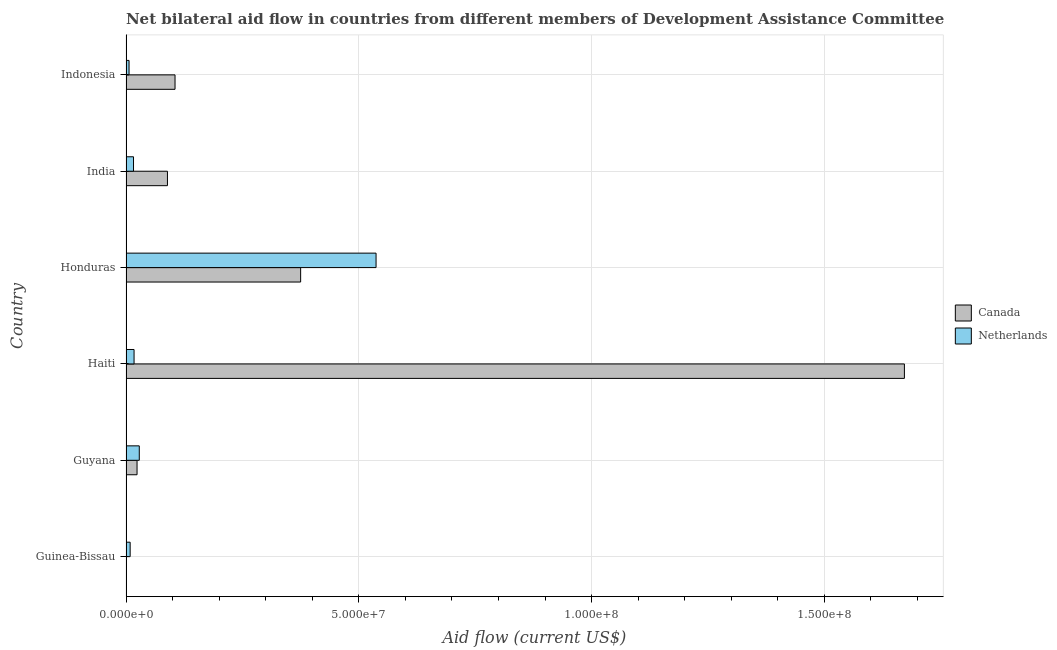How many different coloured bars are there?
Offer a terse response. 2. How many groups of bars are there?
Provide a succinct answer. 6. Are the number of bars on each tick of the Y-axis equal?
Give a very brief answer. Yes. How many bars are there on the 6th tick from the top?
Offer a very short reply. 2. What is the label of the 5th group of bars from the top?
Your answer should be compact. Guyana. In how many cases, is the number of bars for a given country not equal to the number of legend labels?
Your answer should be very brief. 0. What is the amount of aid given by canada in Guyana?
Keep it short and to the point. 2.37e+06. Across all countries, what is the maximum amount of aid given by canada?
Offer a very short reply. 1.67e+08. Across all countries, what is the minimum amount of aid given by netherlands?
Provide a short and direct response. 6.50e+05. In which country was the amount of aid given by canada maximum?
Provide a short and direct response. Haiti. What is the total amount of aid given by canada in the graph?
Your answer should be compact. 2.27e+08. What is the difference between the amount of aid given by canada in Guyana and that in Honduras?
Keep it short and to the point. -3.51e+07. What is the difference between the amount of aid given by canada in Indonesia and the amount of aid given by netherlands in India?
Give a very brief answer. 8.92e+06. What is the average amount of aid given by canada per country?
Your response must be concise. 3.78e+07. What is the difference between the amount of aid given by netherlands and amount of aid given by canada in Guyana?
Offer a very short reply. 4.80e+05. In how many countries, is the amount of aid given by canada greater than 110000000 US$?
Your answer should be compact. 1. What is the ratio of the amount of aid given by canada in Honduras to that in Indonesia?
Your response must be concise. 3.56. What is the difference between the highest and the second highest amount of aid given by canada?
Offer a very short reply. 1.30e+08. What is the difference between the highest and the lowest amount of aid given by canada?
Make the answer very short. 1.67e+08. What does the 2nd bar from the top in India represents?
Your answer should be compact. Canada. Are all the bars in the graph horizontal?
Your response must be concise. Yes. What is the difference between two consecutive major ticks on the X-axis?
Provide a succinct answer. 5.00e+07. Are the values on the major ticks of X-axis written in scientific E-notation?
Offer a terse response. Yes. Does the graph contain any zero values?
Your response must be concise. No. Where does the legend appear in the graph?
Ensure brevity in your answer.  Center right. How are the legend labels stacked?
Offer a terse response. Vertical. What is the title of the graph?
Ensure brevity in your answer.  Net bilateral aid flow in countries from different members of Development Assistance Committee. What is the label or title of the X-axis?
Give a very brief answer. Aid flow (current US$). What is the Aid flow (current US$) of Canada in Guinea-Bissau?
Your answer should be compact. 5.00e+04. What is the Aid flow (current US$) of Netherlands in Guinea-Bissau?
Offer a very short reply. 8.90e+05. What is the Aid flow (current US$) in Canada in Guyana?
Your answer should be very brief. 2.37e+06. What is the Aid flow (current US$) of Netherlands in Guyana?
Give a very brief answer. 2.85e+06. What is the Aid flow (current US$) of Canada in Haiti?
Provide a short and direct response. 1.67e+08. What is the Aid flow (current US$) in Netherlands in Haiti?
Give a very brief answer. 1.73e+06. What is the Aid flow (current US$) of Canada in Honduras?
Your answer should be very brief. 3.75e+07. What is the Aid flow (current US$) in Netherlands in Honduras?
Your answer should be compact. 5.37e+07. What is the Aid flow (current US$) of Canada in India?
Your answer should be compact. 8.90e+06. What is the Aid flow (current US$) in Netherlands in India?
Give a very brief answer. 1.61e+06. What is the Aid flow (current US$) of Canada in Indonesia?
Give a very brief answer. 1.05e+07. What is the Aid flow (current US$) in Netherlands in Indonesia?
Give a very brief answer. 6.50e+05. Across all countries, what is the maximum Aid flow (current US$) in Canada?
Provide a short and direct response. 1.67e+08. Across all countries, what is the maximum Aid flow (current US$) of Netherlands?
Offer a very short reply. 5.37e+07. Across all countries, what is the minimum Aid flow (current US$) of Canada?
Give a very brief answer. 5.00e+04. Across all countries, what is the minimum Aid flow (current US$) in Netherlands?
Provide a succinct answer. 6.50e+05. What is the total Aid flow (current US$) in Canada in the graph?
Your answer should be very brief. 2.27e+08. What is the total Aid flow (current US$) in Netherlands in the graph?
Keep it short and to the point. 6.14e+07. What is the difference between the Aid flow (current US$) of Canada in Guinea-Bissau and that in Guyana?
Your answer should be very brief. -2.32e+06. What is the difference between the Aid flow (current US$) of Netherlands in Guinea-Bissau and that in Guyana?
Provide a succinct answer. -1.96e+06. What is the difference between the Aid flow (current US$) of Canada in Guinea-Bissau and that in Haiti?
Keep it short and to the point. -1.67e+08. What is the difference between the Aid flow (current US$) in Netherlands in Guinea-Bissau and that in Haiti?
Provide a short and direct response. -8.40e+05. What is the difference between the Aid flow (current US$) in Canada in Guinea-Bissau and that in Honduras?
Your answer should be very brief. -3.75e+07. What is the difference between the Aid flow (current US$) in Netherlands in Guinea-Bissau and that in Honduras?
Keep it short and to the point. -5.28e+07. What is the difference between the Aid flow (current US$) of Canada in Guinea-Bissau and that in India?
Provide a succinct answer. -8.85e+06. What is the difference between the Aid flow (current US$) in Netherlands in Guinea-Bissau and that in India?
Ensure brevity in your answer.  -7.20e+05. What is the difference between the Aid flow (current US$) of Canada in Guinea-Bissau and that in Indonesia?
Ensure brevity in your answer.  -1.05e+07. What is the difference between the Aid flow (current US$) in Canada in Guyana and that in Haiti?
Ensure brevity in your answer.  -1.65e+08. What is the difference between the Aid flow (current US$) of Netherlands in Guyana and that in Haiti?
Your answer should be compact. 1.12e+06. What is the difference between the Aid flow (current US$) in Canada in Guyana and that in Honduras?
Provide a short and direct response. -3.51e+07. What is the difference between the Aid flow (current US$) of Netherlands in Guyana and that in Honduras?
Ensure brevity in your answer.  -5.09e+07. What is the difference between the Aid flow (current US$) in Canada in Guyana and that in India?
Your answer should be very brief. -6.53e+06. What is the difference between the Aid flow (current US$) in Netherlands in Guyana and that in India?
Make the answer very short. 1.24e+06. What is the difference between the Aid flow (current US$) of Canada in Guyana and that in Indonesia?
Give a very brief answer. -8.16e+06. What is the difference between the Aid flow (current US$) of Netherlands in Guyana and that in Indonesia?
Offer a terse response. 2.20e+06. What is the difference between the Aid flow (current US$) in Canada in Haiti and that in Honduras?
Ensure brevity in your answer.  1.30e+08. What is the difference between the Aid flow (current US$) in Netherlands in Haiti and that in Honduras?
Offer a terse response. -5.20e+07. What is the difference between the Aid flow (current US$) of Canada in Haiti and that in India?
Provide a succinct answer. 1.58e+08. What is the difference between the Aid flow (current US$) of Canada in Haiti and that in Indonesia?
Your response must be concise. 1.57e+08. What is the difference between the Aid flow (current US$) of Netherlands in Haiti and that in Indonesia?
Your response must be concise. 1.08e+06. What is the difference between the Aid flow (current US$) in Canada in Honduras and that in India?
Make the answer very short. 2.86e+07. What is the difference between the Aid flow (current US$) in Netherlands in Honduras and that in India?
Ensure brevity in your answer.  5.21e+07. What is the difference between the Aid flow (current US$) of Canada in Honduras and that in Indonesia?
Your response must be concise. 2.70e+07. What is the difference between the Aid flow (current US$) in Netherlands in Honduras and that in Indonesia?
Keep it short and to the point. 5.31e+07. What is the difference between the Aid flow (current US$) in Canada in India and that in Indonesia?
Your response must be concise. -1.63e+06. What is the difference between the Aid flow (current US$) of Netherlands in India and that in Indonesia?
Your answer should be very brief. 9.60e+05. What is the difference between the Aid flow (current US$) in Canada in Guinea-Bissau and the Aid flow (current US$) in Netherlands in Guyana?
Your answer should be very brief. -2.80e+06. What is the difference between the Aid flow (current US$) of Canada in Guinea-Bissau and the Aid flow (current US$) of Netherlands in Haiti?
Provide a succinct answer. -1.68e+06. What is the difference between the Aid flow (current US$) of Canada in Guinea-Bissau and the Aid flow (current US$) of Netherlands in Honduras?
Offer a terse response. -5.37e+07. What is the difference between the Aid flow (current US$) in Canada in Guinea-Bissau and the Aid flow (current US$) in Netherlands in India?
Your response must be concise. -1.56e+06. What is the difference between the Aid flow (current US$) of Canada in Guinea-Bissau and the Aid flow (current US$) of Netherlands in Indonesia?
Keep it short and to the point. -6.00e+05. What is the difference between the Aid flow (current US$) in Canada in Guyana and the Aid flow (current US$) in Netherlands in Haiti?
Provide a succinct answer. 6.40e+05. What is the difference between the Aid flow (current US$) in Canada in Guyana and the Aid flow (current US$) in Netherlands in Honduras?
Your answer should be very brief. -5.13e+07. What is the difference between the Aid flow (current US$) of Canada in Guyana and the Aid flow (current US$) of Netherlands in India?
Ensure brevity in your answer.  7.60e+05. What is the difference between the Aid flow (current US$) of Canada in Guyana and the Aid flow (current US$) of Netherlands in Indonesia?
Your answer should be compact. 1.72e+06. What is the difference between the Aid flow (current US$) in Canada in Haiti and the Aid flow (current US$) in Netherlands in Honduras?
Your answer should be compact. 1.13e+08. What is the difference between the Aid flow (current US$) in Canada in Haiti and the Aid flow (current US$) in Netherlands in India?
Your response must be concise. 1.66e+08. What is the difference between the Aid flow (current US$) in Canada in Haiti and the Aid flow (current US$) in Netherlands in Indonesia?
Provide a succinct answer. 1.67e+08. What is the difference between the Aid flow (current US$) in Canada in Honduras and the Aid flow (current US$) in Netherlands in India?
Provide a succinct answer. 3.59e+07. What is the difference between the Aid flow (current US$) in Canada in Honduras and the Aid flow (current US$) in Netherlands in Indonesia?
Your answer should be compact. 3.69e+07. What is the difference between the Aid flow (current US$) in Canada in India and the Aid flow (current US$) in Netherlands in Indonesia?
Your answer should be compact. 8.25e+06. What is the average Aid flow (current US$) of Canada per country?
Ensure brevity in your answer.  3.78e+07. What is the average Aid flow (current US$) in Netherlands per country?
Provide a short and direct response. 1.02e+07. What is the difference between the Aid flow (current US$) of Canada and Aid flow (current US$) of Netherlands in Guinea-Bissau?
Your response must be concise. -8.40e+05. What is the difference between the Aid flow (current US$) in Canada and Aid flow (current US$) in Netherlands in Guyana?
Provide a short and direct response. -4.80e+05. What is the difference between the Aid flow (current US$) of Canada and Aid flow (current US$) of Netherlands in Haiti?
Offer a terse response. 1.65e+08. What is the difference between the Aid flow (current US$) in Canada and Aid flow (current US$) in Netherlands in Honduras?
Ensure brevity in your answer.  -1.62e+07. What is the difference between the Aid flow (current US$) of Canada and Aid flow (current US$) of Netherlands in India?
Give a very brief answer. 7.29e+06. What is the difference between the Aid flow (current US$) in Canada and Aid flow (current US$) in Netherlands in Indonesia?
Ensure brevity in your answer.  9.88e+06. What is the ratio of the Aid flow (current US$) of Canada in Guinea-Bissau to that in Guyana?
Offer a terse response. 0.02. What is the ratio of the Aid flow (current US$) of Netherlands in Guinea-Bissau to that in Guyana?
Your response must be concise. 0.31. What is the ratio of the Aid flow (current US$) in Canada in Guinea-Bissau to that in Haiti?
Offer a terse response. 0. What is the ratio of the Aid flow (current US$) of Netherlands in Guinea-Bissau to that in Haiti?
Your answer should be compact. 0.51. What is the ratio of the Aid flow (current US$) of Canada in Guinea-Bissau to that in Honduras?
Your response must be concise. 0. What is the ratio of the Aid flow (current US$) of Netherlands in Guinea-Bissau to that in Honduras?
Give a very brief answer. 0.02. What is the ratio of the Aid flow (current US$) in Canada in Guinea-Bissau to that in India?
Offer a very short reply. 0.01. What is the ratio of the Aid flow (current US$) in Netherlands in Guinea-Bissau to that in India?
Ensure brevity in your answer.  0.55. What is the ratio of the Aid flow (current US$) of Canada in Guinea-Bissau to that in Indonesia?
Provide a succinct answer. 0. What is the ratio of the Aid flow (current US$) of Netherlands in Guinea-Bissau to that in Indonesia?
Offer a very short reply. 1.37. What is the ratio of the Aid flow (current US$) of Canada in Guyana to that in Haiti?
Your answer should be very brief. 0.01. What is the ratio of the Aid flow (current US$) in Netherlands in Guyana to that in Haiti?
Provide a short and direct response. 1.65. What is the ratio of the Aid flow (current US$) in Canada in Guyana to that in Honduras?
Your answer should be very brief. 0.06. What is the ratio of the Aid flow (current US$) of Netherlands in Guyana to that in Honduras?
Provide a short and direct response. 0.05. What is the ratio of the Aid flow (current US$) in Canada in Guyana to that in India?
Your answer should be very brief. 0.27. What is the ratio of the Aid flow (current US$) of Netherlands in Guyana to that in India?
Offer a very short reply. 1.77. What is the ratio of the Aid flow (current US$) in Canada in Guyana to that in Indonesia?
Your answer should be compact. 0.23. What is the ratio of the Aid flow (current US$) of Netherlands in Guyana to that in Indonesia?
Make the answer very short. 4.38. What is the ratio of the Aid flow (current US$) of Canada in Haiti to that in Honduras?
Your response must be concise. 4.46. What is the ratio of the Aid flow (current US$) of Netherlands in Haiti to that in Honduras?
Keep it short and to the point. 0.03. What is the ratio of the Aid flow (current US$) of Canada in Haiti to that in India?
Your answer should be very brief. 18.79. What is the ratio of the Aid flow (current US$) in Netherlands in Haiti to that in India?
Provide a succinct answer. 1.07. What is the ratio of the Aid flow (current US$) of Canada in Haiti to that in Indonesia?
Your response must be concise. 15.88. What is the ratio of the Aid flow (current US$) of Netherlands in Haiti to that in Indonesia?
Keep it short and to the point. 2.66. What is the ratio of the Aid flow (current US$) in Canada in Honduras to that in India?
Your answer should be compact. 4.21. What is the ratio of the Aid flow (current US$) in Netherlands in Honduras to that in India?
Make the answer very short. 33.36. What is the ratio of the Aid flow (current US$) in Canada in Honduras to that in Indonesia?
Provide a short and direct response. 3.56. What is the ratio of the Aid flow (current US$) of Netherlands in Honduras to that in Indonesia?
Ensure brevity in your answer.  82.63. What is the ratio of the Aid flow (current US$) in Canada in India to that in Indonesia?
Give a very brief answer. 0.85. What is the ratio of the Aid flow (current US$) of Netherlands in India to that in Indonesia?
Give a very brief answer. 2.48. What is the difference between the highest and the second highest Aid flow (current US$) in Canada?
Your response must be concise. 1.30e+08. What is the difference between the highest and the second highest Aid flow (current US$) of Netherlands?
Provide a short and direct response. 5.09e+07. What is the difference between the highest and the lowest Aid flow (current US$) in Canada?
Give a very brief answer. 1.67e+08. What is the difference between the highest and the lowest Aid flow (current US$) in Netherlands?
Provide a short and direct response. 5.31e+07. 